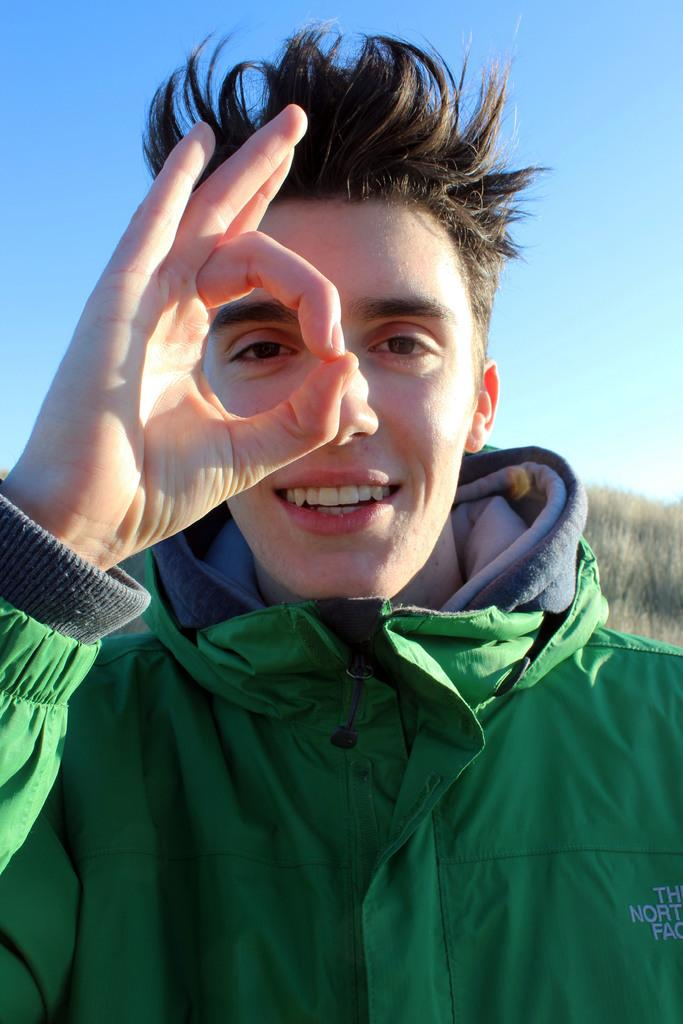What is present in the image? There is a person in the image. Can you describe the person's clothing? The person is wearing a green jacket. What can be seen in the background of the image? There is sky visible in the background of the image. What type of lunch is the person eating in the image? There is no indication in the image that the person is eating lunch, so it cannot be determined from the picture. 